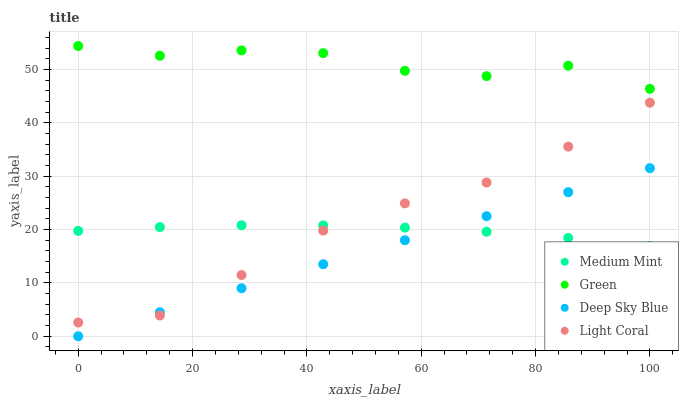Does Deep Sky Blue have the minimum area under the curve?
Answer yes or no. Yes. Does Green have the maximum area under the curve?
Answer yes or no. Yes. Does Light Coral have the minimum area under the curve?
Answer yes or no. No. Does Light Coral have the maximum area under the curve?
Answer yes or no. No. Is Deep Sky Blue the smoothest?
Answer yes or no. Yes. Is Green the roughest?
Answer yes or no. Yes. Is Light Coral the smoothest?
Answer yes or no. No. Is Light Coral the roughest?
Answer yes or no. No. Does Deep Sky Blue have the lowest value?
Answer yes or no. Yes. Does Light Coral have the lowest value?
Answer yes or no. No. Does Green have the highest value?
Answer yes or no. Yes. Does Light Coral have the highest value?
Answer yes or no. No. Is Light Coral less than Green?
Answer yes or no. Yes. Is Green greater than Deep Sky Blue?
Answer yes or no. Yes. Does Medium Mint intersect Deep Sky Blue?
Answer yes or no. Yes. Is Medium Mint less than Deep Sky Blue?
Answer yes or no. No. Is Medium Mint greater than Deep Sky Blue?
Answer yes or no. No. Does Light Coral intersect Green?
Answer yes or no. No. 